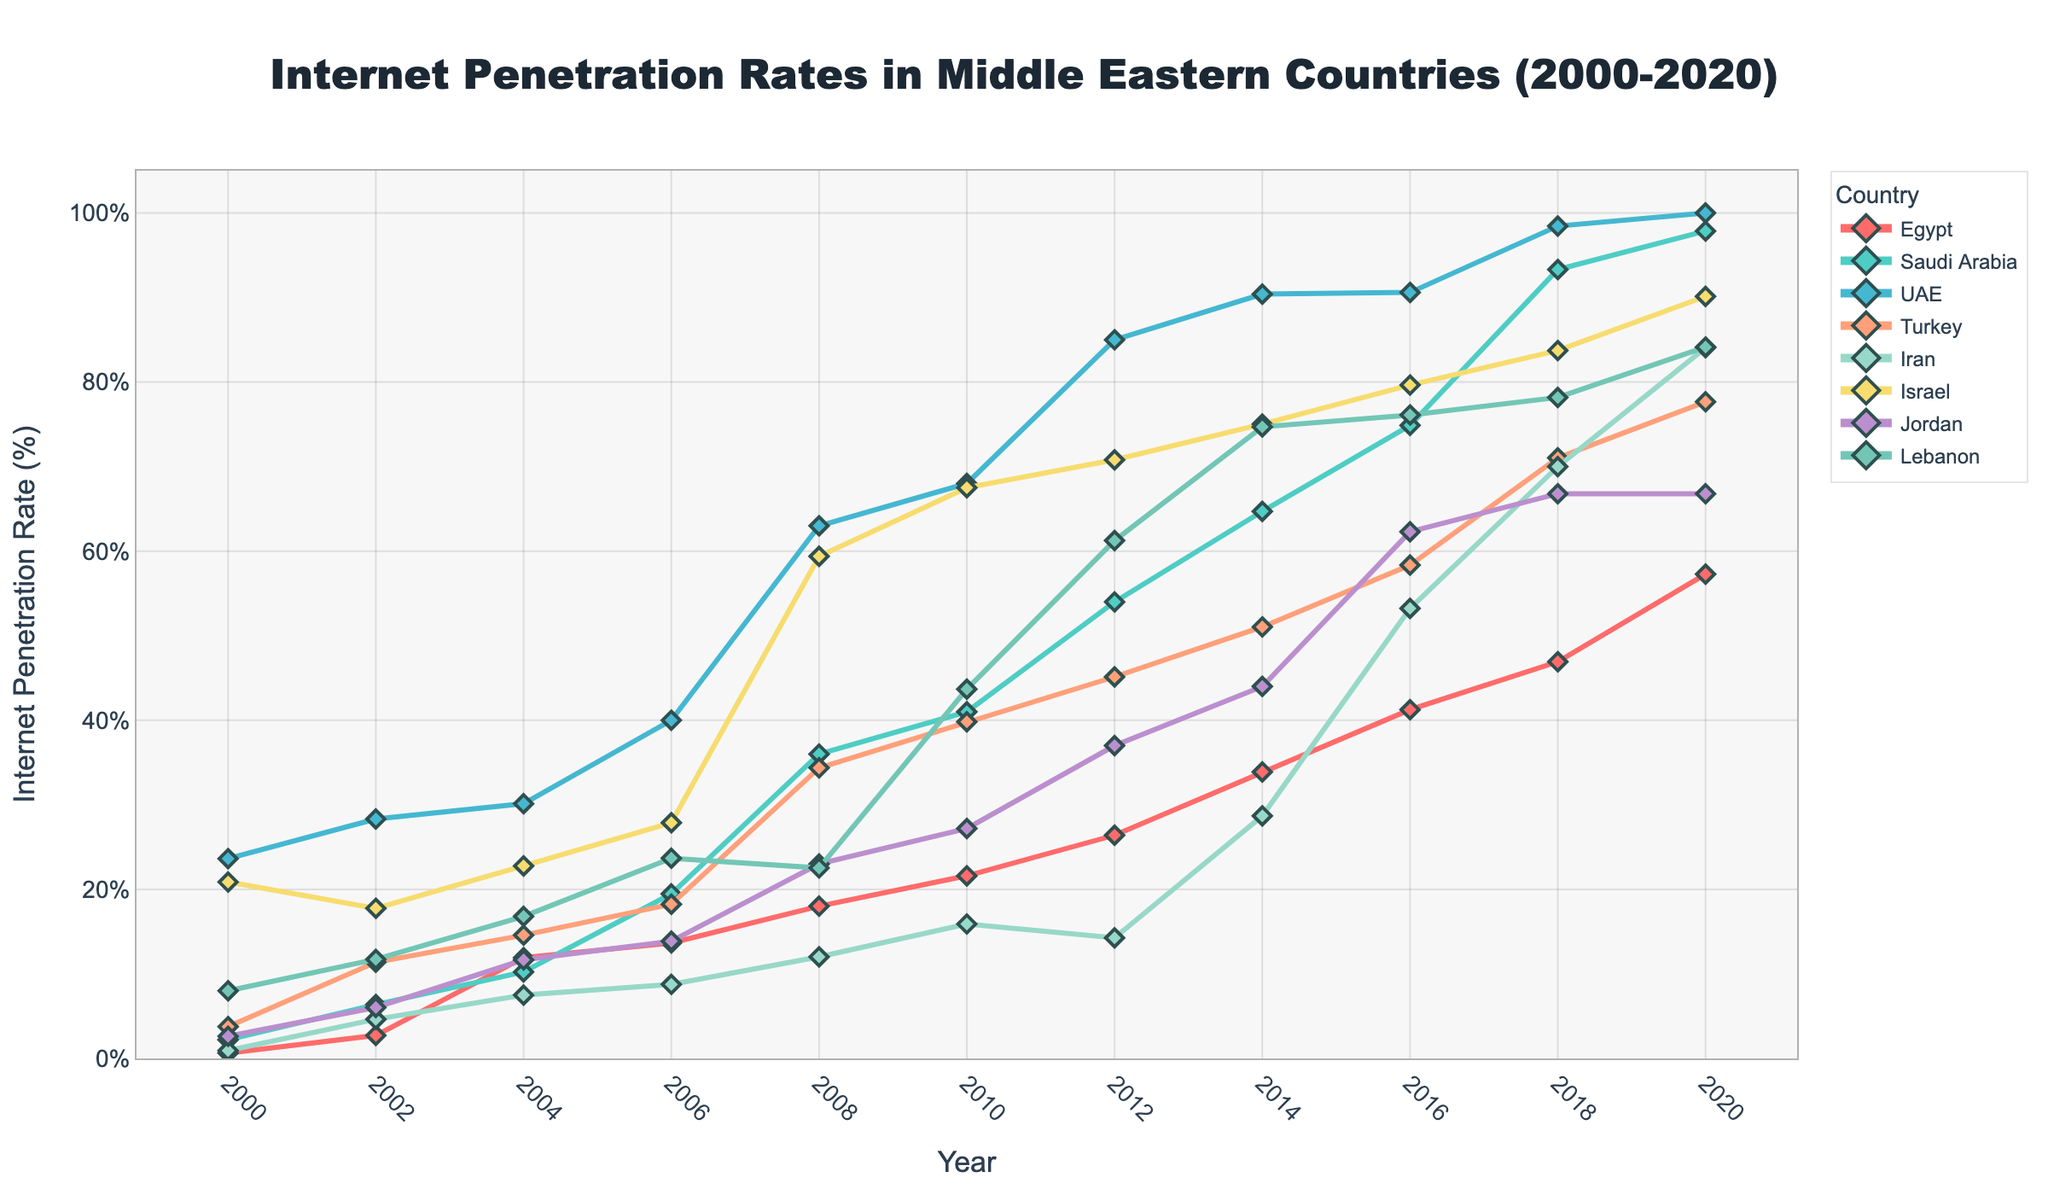Which country experienced the highest internet penetration rate in 2020? The figure shows the evolution of internet penetration rates across several Middle Eastern countries. In 2020, UAE achieved a 100% penetration rate, which is the highest among all listed countries.
Answer: UAE How did the internet penetration rate in Egypt evolve from 2000 to 2020? To answer this, locate the line representing Egypt on the chart and observe its progression across the years from 2000 to 2020. The rate increased from 0.64% in 2000 to 57.28% in 2020, indicating substantial growth over the two decades.
Answer: Increased from 0.64% to 57.28% Which countries had an internet penetration rate exceeding 90% by 2020? Look at the 2020 data points for each country on the figure. UAE (100%), Saudi Arabia (97.86%), and Israel (90.13%) had internet penetration rates exceeding 90% in 2020.
Answer: UAE, Saudi Arabia, Israel Compare the internet penetration rate of Turkey and Iran in 2010. Which country had a higher rate? From the 2010 data points on the chart, Turkey had a rate of 39.82%, while Iran had a rate of 15.90%. Thus, Turkey had a higher penetration rate than Iran in 2010.
Answer: Turkey Between 2006 and 2008, which country experienced the highest increase in internet penetration rate? Calculate the change in internet penetration rates for each country between 2006 and 2008. The most significant increase can be observed for UAE, where the rate jumped from 40% in 2006 to 63% in 2008, indicating an increase of 23%.
Answer: UAE What was the average internet penetration rate of Lebanon between 2002 and 2012? Average the rates of Lebanon for the years 2002, 2004, 2006, 2008, 2010, and 2012: (11.72 + 16.80 + 23.68 + 22.53 + 43.68 + 61.25) / 6 = (179.66) / 6 = 29.94%.
Answer: 29.94% Which country had a nearly constant internet penetration rate between 2006 and 2008? Observe the trend lines of each country between 2006 and 2008. Israel's line shows minimal change, indicating nearly constant values with a minor increase from 27.88% to 59.39%, which visually appears consistent in its growth pace compared to others.
Answer: Israel What is the difference in internet penetration rates between UAE and Jordan in 2020? From the 2020 data points, UAE has a rate of 100% and Jordan has a rate of 66.79%. The difference is 100% - 66.79% = 33.21%.
Answer: 33.21% Identify the year when Egypt first crossed the 20% internet penetration rate. Follow the line representing Egypt and look for the first year where the rate surpasses 20%. In the year 2010, Egypt's rate was 21.60%, indicating it first crossed the 20% threshold.
Answer: 2010 